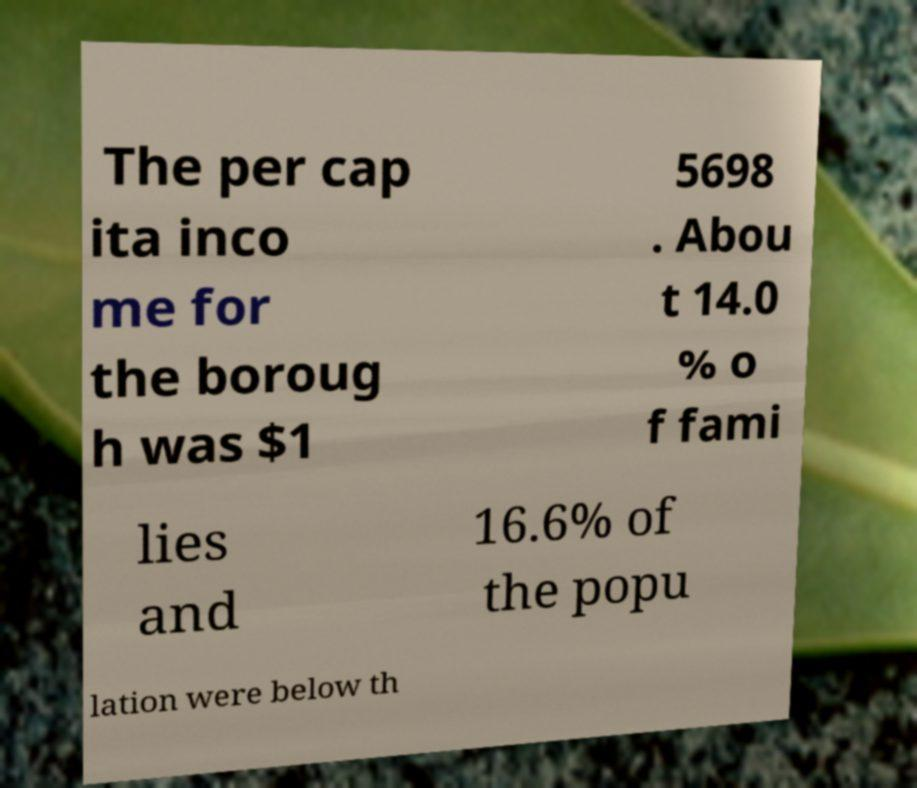Please read and relay the text visible in this image. What does it say? The per cap ita inco me for the boroug h was $1 5698 . Abou t 14.0 % o f fami lies and 16.6% of the popu lation were below th 